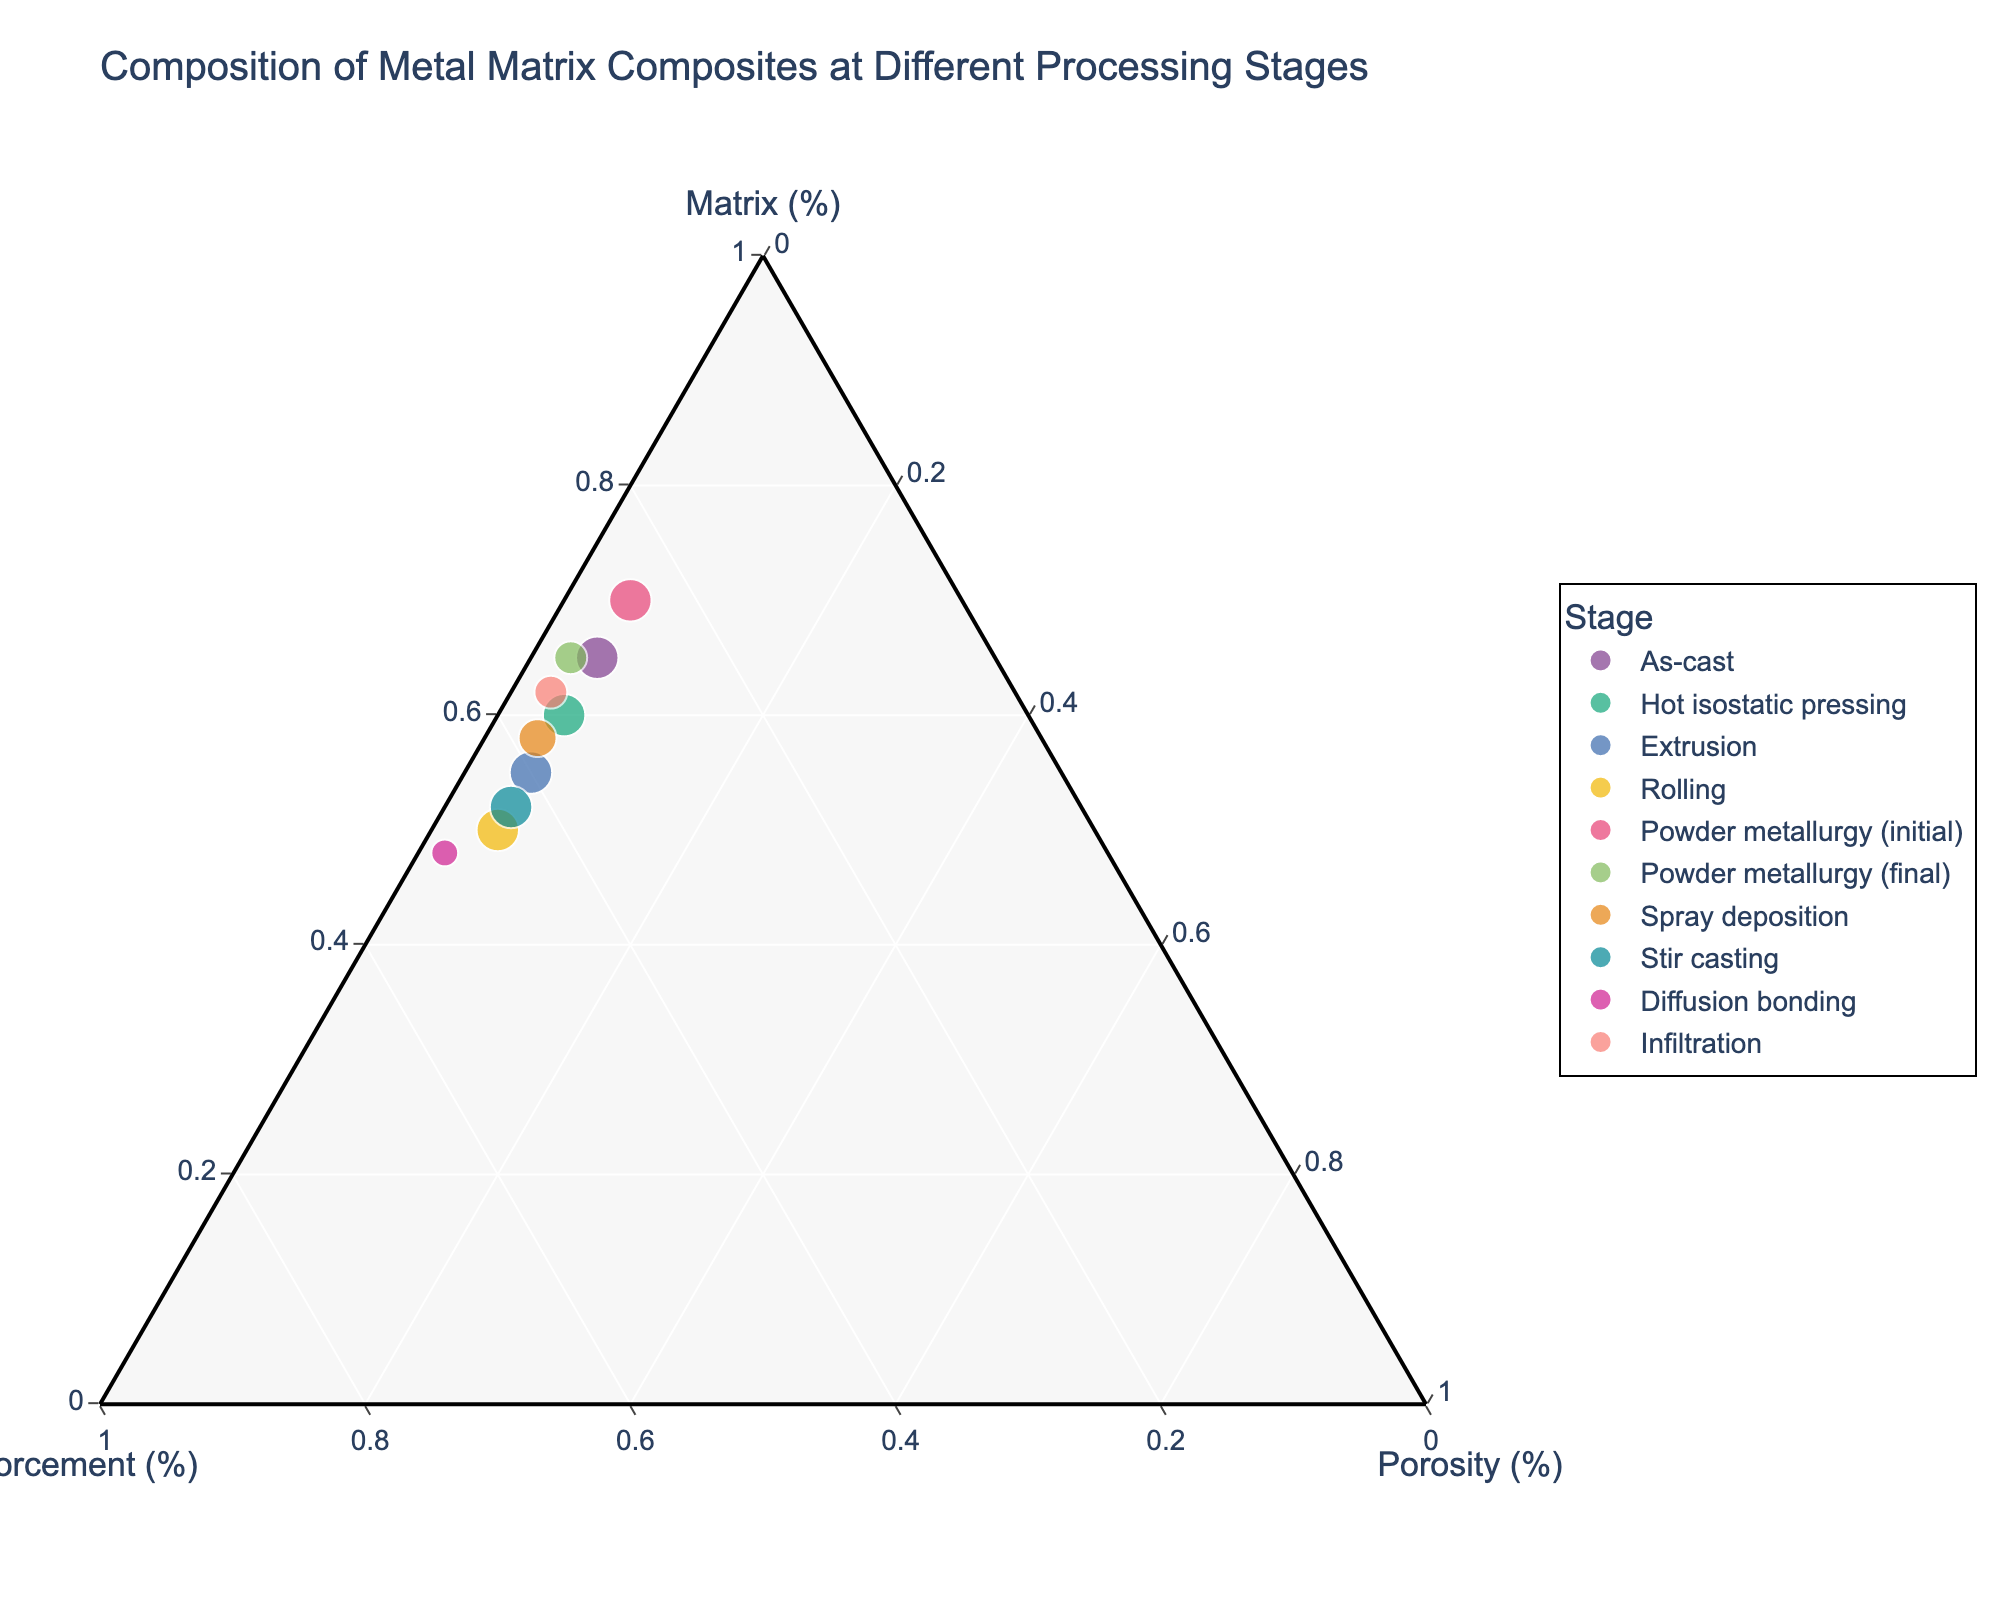How many processing stages are depicted in the ternary plot? Count the distinct stages shown in the legend of the ternary plot.
Answer: 10 Which processing stage has the highest reinforcement percentage? Locate the data point with the highest value along the Reinforcement axis.
Answer: Diffusion bonding Which processing stage starts with the highest Matrix proportion and finishes with a different proportion? Identify the processing stage in the title or color legend that shows changes from an initial to final stage. Compare its initial and final proportions for Matrix.
Answer: Powder metallurgy What is the Porosity percentage across all processing stages? All data points show the same Porosity percentage when viewed; typically stated or visually confirmed in the hover template.
Answer: Mostly 5% Compare the Matrix contributions between "Hot isostatic pressing" and "Spray deposition". Which one is greater? Find the data points for these stages and compare the values along the Matrix axis.
Answer: Hot isostatic pressing What's the collective sum of Matrix proportions in "Rolling" and "Extrusion"? Locate these two data points, sum the Matrix values. Rolling: 50, Extrusion: 55. Thus, 50 + 55 is the total.
Answer: 105 Identify the stage with the lowest Porosity value. Examine the data points for the one with the smallest circle, given Porosity sizes represent relative values.
Answer: Diffusion bonding (2%) What is the difference in Reinforcement percentages between "As-cast" and "Infiltration"? Subtract the Reinforcement value of "Infiltration" from "As-cast". As-cast: 30, Infiltration: 35. Calculate the difference, 30 - 35.
Answer: -5 Which stages maintain the same Porosity value? Identify stages that have overlapping Porosity values in hover information or size of markers. Most stages show Porosity of 5%.
Answer: Most stages, but notably, "As-cast", "Hot isostatic pressing", "Extrusion", "Rolling" In what way does the "Powder metallurgy" process change between its initial and final processing stages? Compare the initial and final values for Matrix, Reinforcement, and Porosity: Initial (70, 25, 5), Final (65, 32, 3). Note the changes in values for each component.
Answer: Decrease in Matrix, Increase in Reinforcement, Decrease in Porosity 